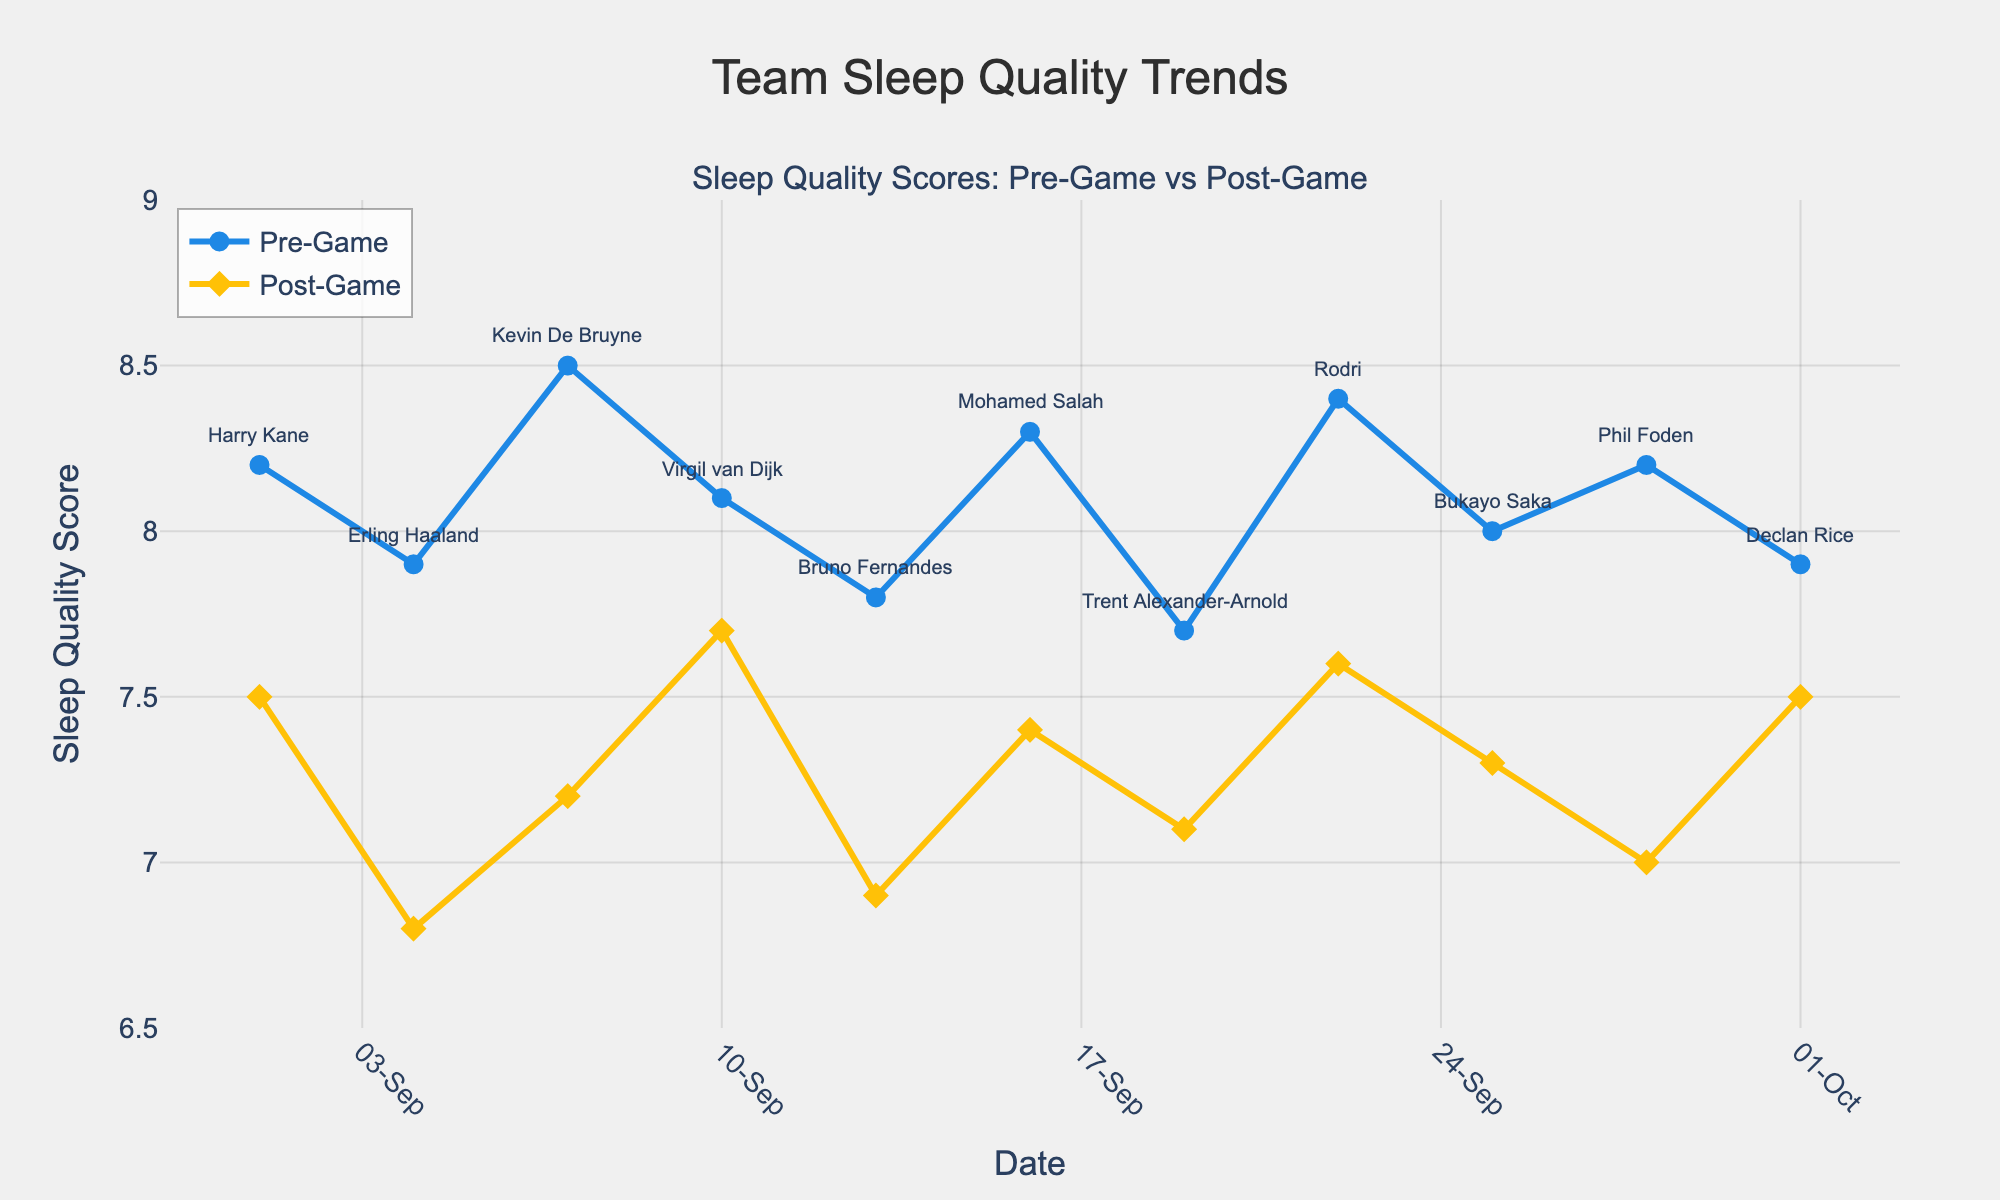Which player's pre-game sleep quality score was the highest? Look for the highest pre-game sleep quality score on the graph. The highest score is 8.5, which belongs to Kevin De Bruyne.
Answer: Kevin De Bruyne How does post-game sleep quality compare to pre-game sleep quality for most players? Compare the post-game sleep quality line to the pre-game sleep quality line. For most players, the post-game sleep quality is lower than their pre-game sleep quality.
Answer: Lower Which player had the smallest difference between pre-game and post-game sleep quality scores? Calculate the difference for each player by subtracting the post-game score from the pre-game score and identify the smallest difference. Virgil van Dijk has the smallest difference, 8.1 - 7.7 = 0.4.
Answer: Virgil van Dijk On which date did the largest drop in sleep quality occur from pre-game to post-game? Look at the dates and identify the largest decrease in sleep quality by subtracting post-game score from pre-game score for each date. Kevin De Bruyne has the largest drop, 8.5 - 7.2 = 1.3.
Answer: 2023-09-07 How many players had a post-game sleep quality score of 7.0 or below? Identify the number of players with post-game scores of 7.0 or below. The players are Erling Haaland (6.8), Bruno Fernandes (6.9), and Phil Foden (7.0).
Answer: 3 Is there a trend in pre-game sleep quality over the month? Examine the pre-game sleep quality line. The scores do not show a consistent upward or downward trend but fluctuate within the range of 7.7 to 8.5.
Answer: No consistent trend Which player’s post-game sleep quality improved compared to their pre-game sleep quality? Look for any instance where the post-game sleep quality score is higher than the pre-game score. No player shows this pattern, all post-game scores are equal to or lower than pre-game scores.
Answer: None 